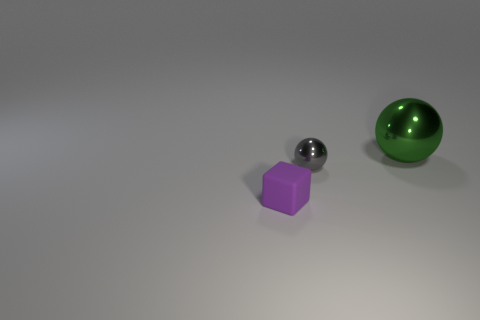Add 1 green objects. How many objects exist? 4 Subtract all spheres. How many objects are left? 1 Subtract all red blocks. Subtract all small purple rubber blocks. How many objects are left? 2 Add 1 gray objects. How many gray objects are left? 2 Add 1 small cyan rubber objects. How many small cyan rubber objects exist? 1 Subtract 0 cyan spheres. How many objects are left? 3 